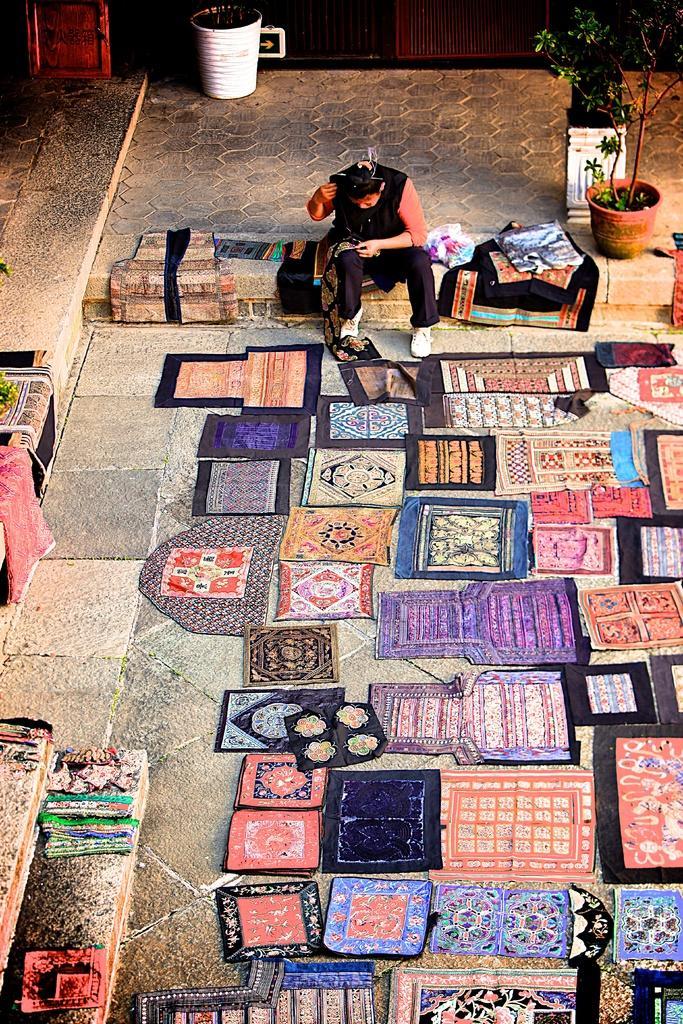Can you describe this image briefly? Here in this picture we can see mats present on the ground over there and we can see person sitting over there and we can see plants present over there. 